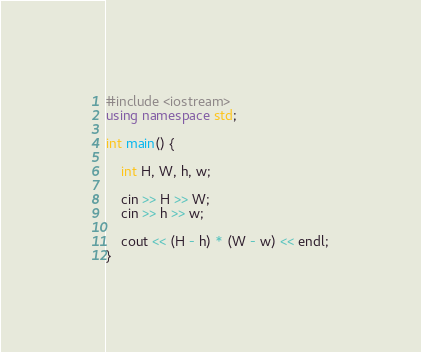Convert code to text. <code><loc_0><loc_0><loc_500><loc_500><_C++_>#include <iostream>
using namespace std;

int main() {

    int H, W, h, w;

    cin >> H >> W;
    cin >> h >> w;

    cout << (H - h) * (W - w) << endl;
}</code> 